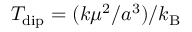Convert formula to latex. <formula><loc_0><loc_0><loc_500><loc_500>T _ { d i p } = ( k \mu ^ { 2 } / a ^ { 3 } ) / k _ { B }</formula> 